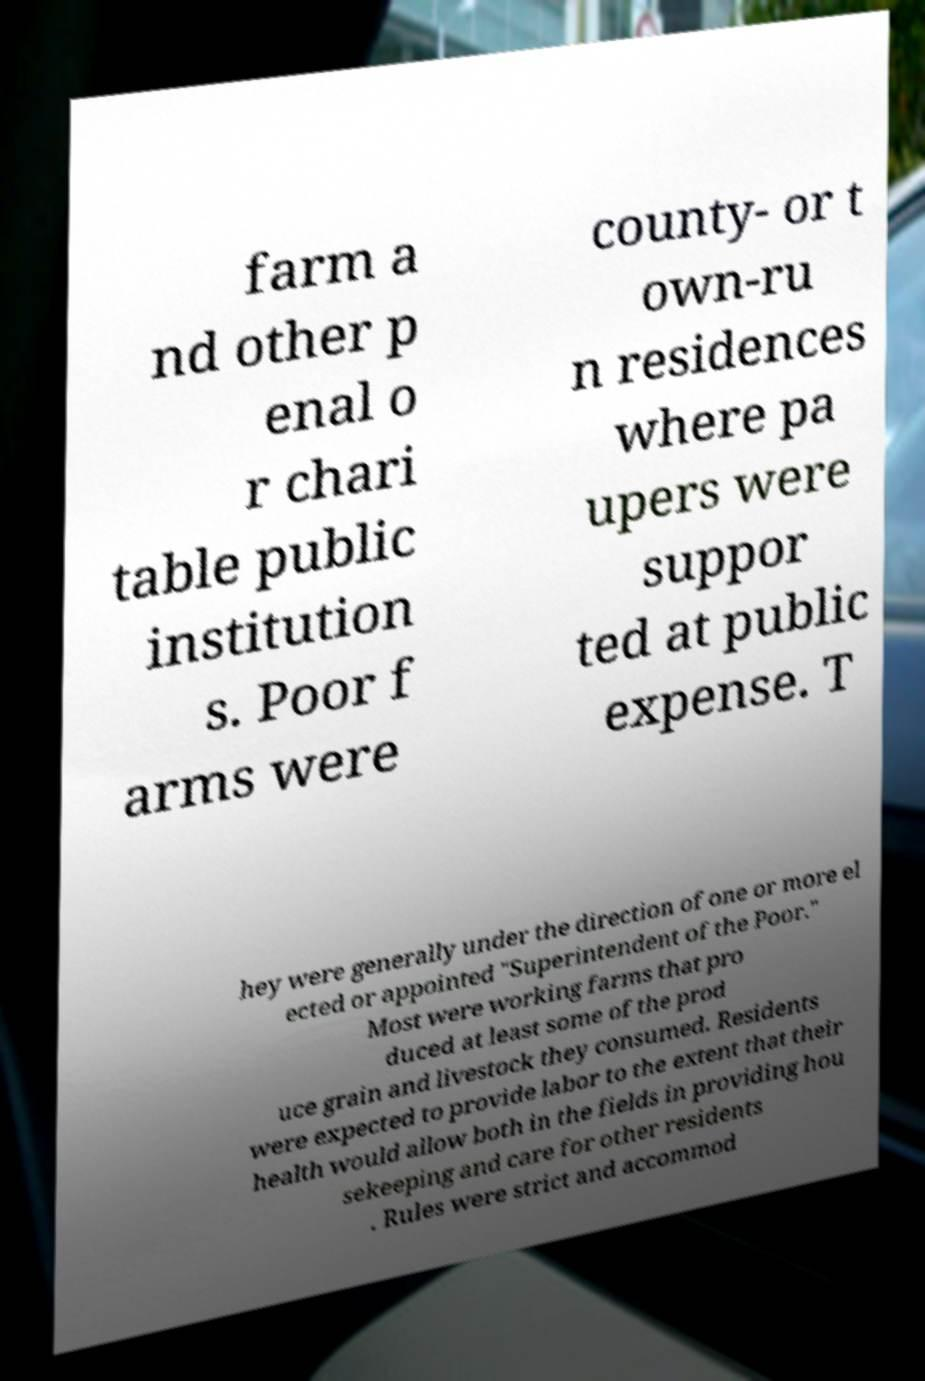Can you read and provide the text displayed in the image?This photo seems to have some interesting text. Can you extract and type it out for me? farm a nd other p enal o r chari table public institution s. Poor f arms were county- or t own-ru n residences where pa upers were suppor ted at public expense. T hey were generally under the direction of one or more el ected or appointed "Superintendent of the Poor." Most were working farms that pro duced at least some of the prod uce grain and livestock they consumed. Residents were expected to provide labor to the extent that their health would allow both in the fields in providing hou sekeeping and care for other residents . Rules were strict and accommod 